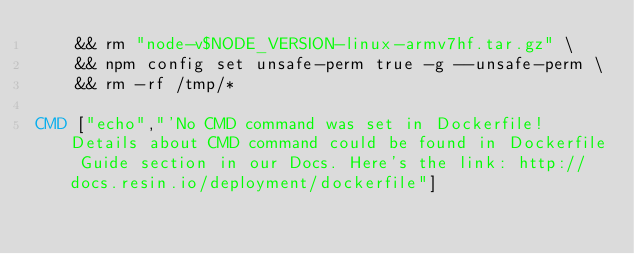Convert code to text. <code><loc_0><loc_0><loc_500><loc_500><_Dockerfile_>	&& rm "node-v$NODE_VERSION-linux-armv7hf.tar.gz" \
	&& npm config set unsafe-perm true -g --unsafe-perm \
	&& rm -rf /tmp/*

CMD ["echo","'No CMD command was set in Dockerfile! Details about CMD command could be found in Dockerfile Guide section in our Docs. Here's the link: http://docs.resin.io/deployment/dockerfile"]
</code> 